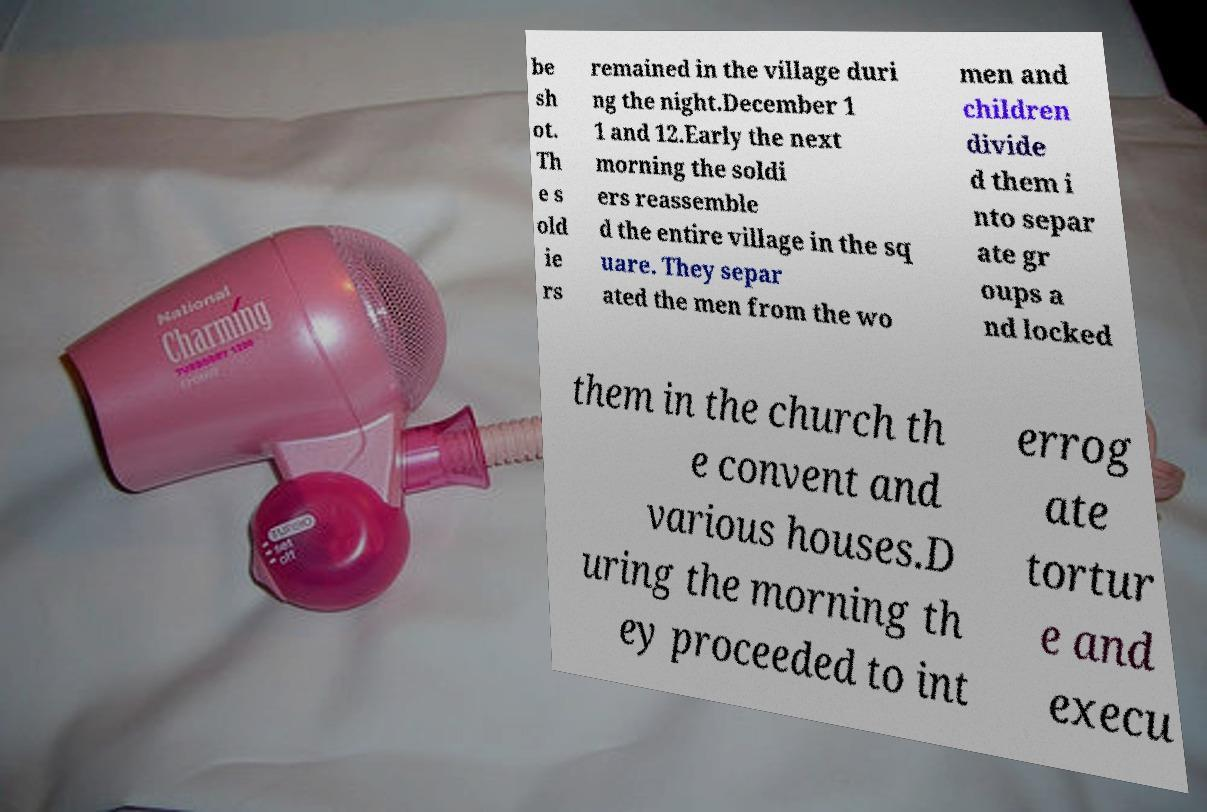Can you read and provide the text displayed in the image?This photo seems to have some interesting text. Can you extract and type it out for me? be sh ot. Th e s old ie rs remained in the village duri ng the night.December 1 1 and 12.Early the next morning the soldi ers reassemble d the entire village in the sq uare. They separ ated the men from the wo men and children divide d them i nto separ ate gr oups a nd locked them in the church th e convent and various houses.D uring the morning th ey proceeded to int errog ate tortur e and execu 